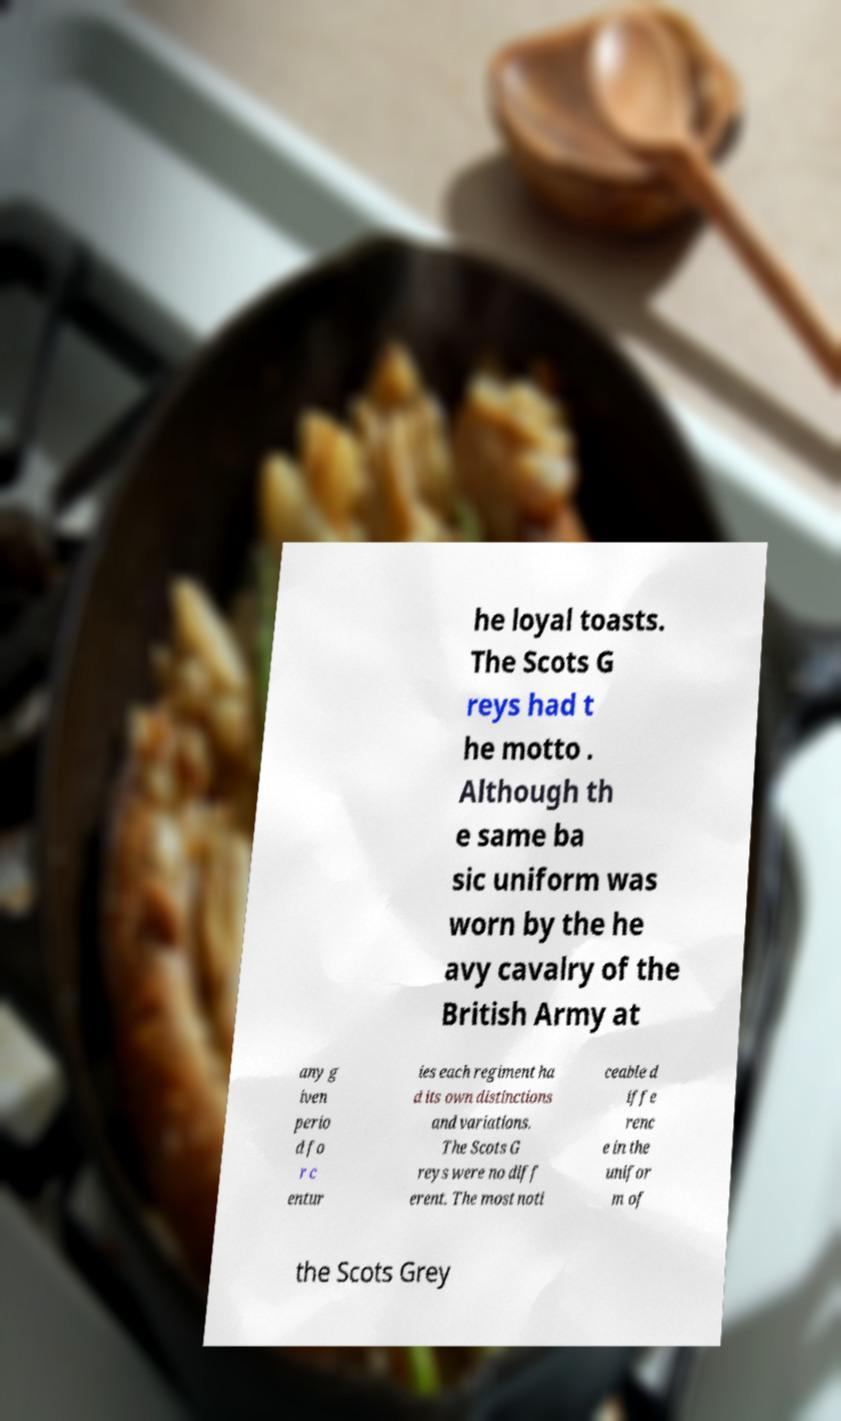Please read and relay the text visible in this image. What does it say? he loyal toasts. The Scots G reys had t he motto . Although th e same ba sic uniform was worn by the he avy cavalry of the British Army at any g iven perio d fo r c entur ies each regiment ha d its own distinctions and variations. The Scots G reys were no diff erent. The most noti ceable d iffe renc e in the unifor m of the Scots Grey 